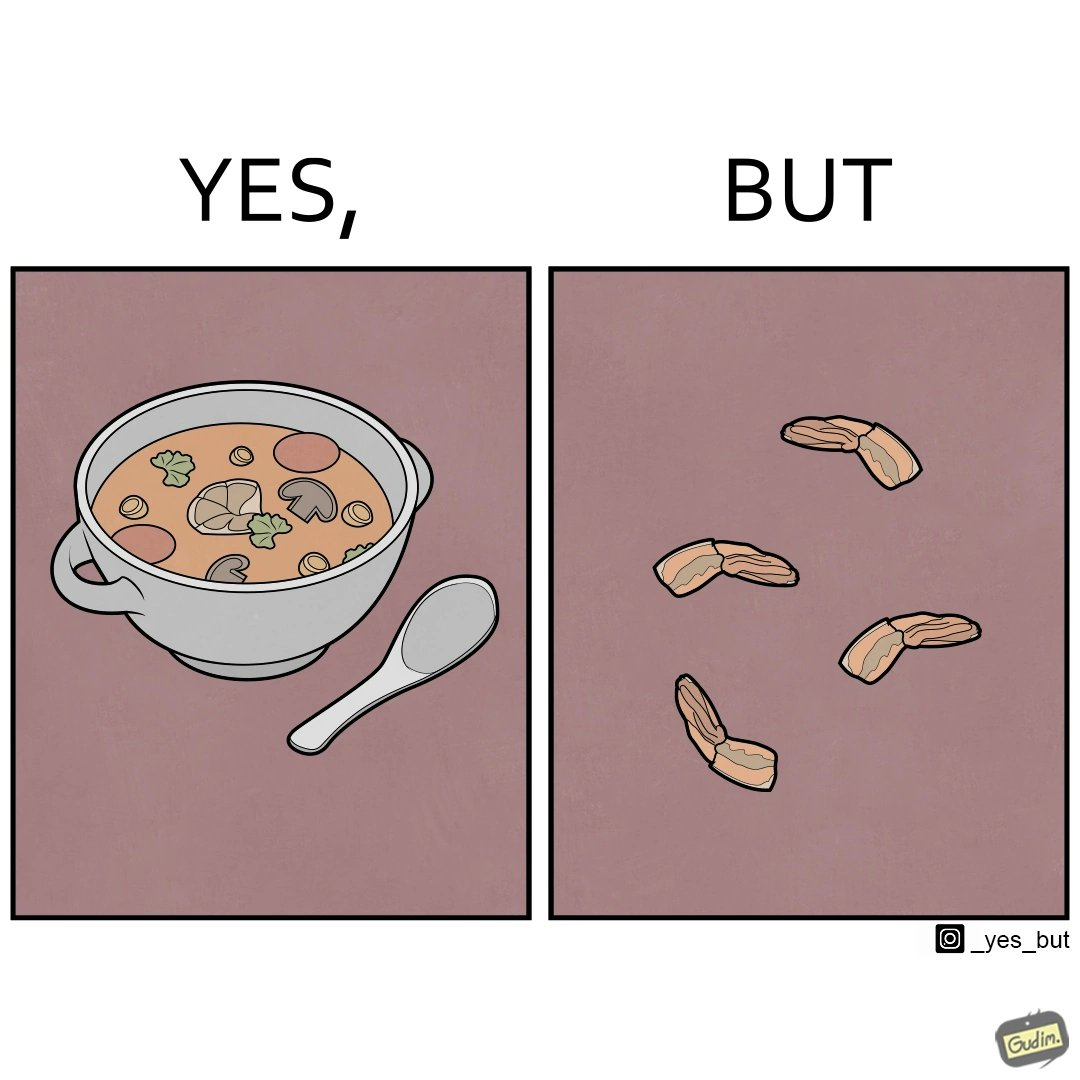Why is this image considered satirical? when we drink the whole soup, then  it is very healthy. But people eliminate some things which they don't like. 